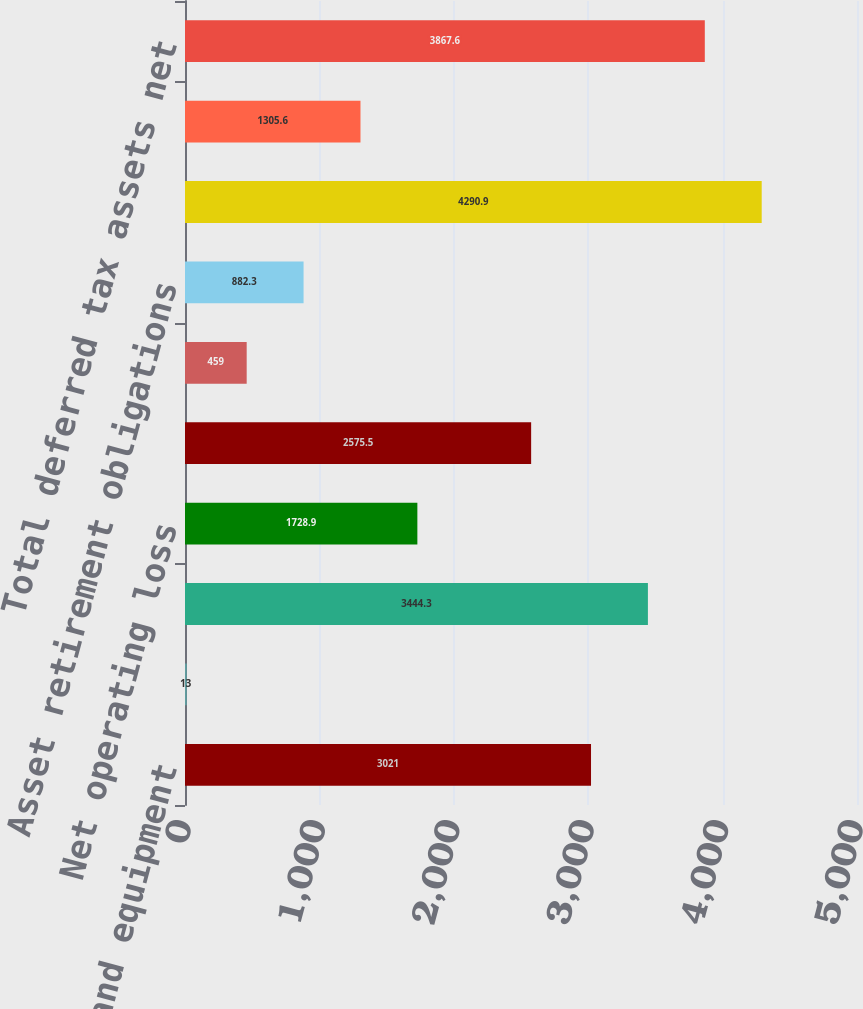<chart> <loc_0><loc_0><loc_500><loc_500><bar_chart><fcel>Property plant and equipment<fcel>Other<fcel>Total deferred tax liabilities<fcel>Net operating loss<fcel>Tax credit carryforwards<fcel>Accrued liabilities<fcel>Asset retirement obligations<fcel>Total deferred tax assets<fcel>Valuation allowance<fcel>Total deferred tax assets net<nl><fcel>3021<fcel>13<fcel>3444.3<fcel>1728.9<fcel>2575.5<fcel>459<fcel>882.3<fcel>4290.9<fcel>1305.6<fcel>3867.6<nl></chart> 